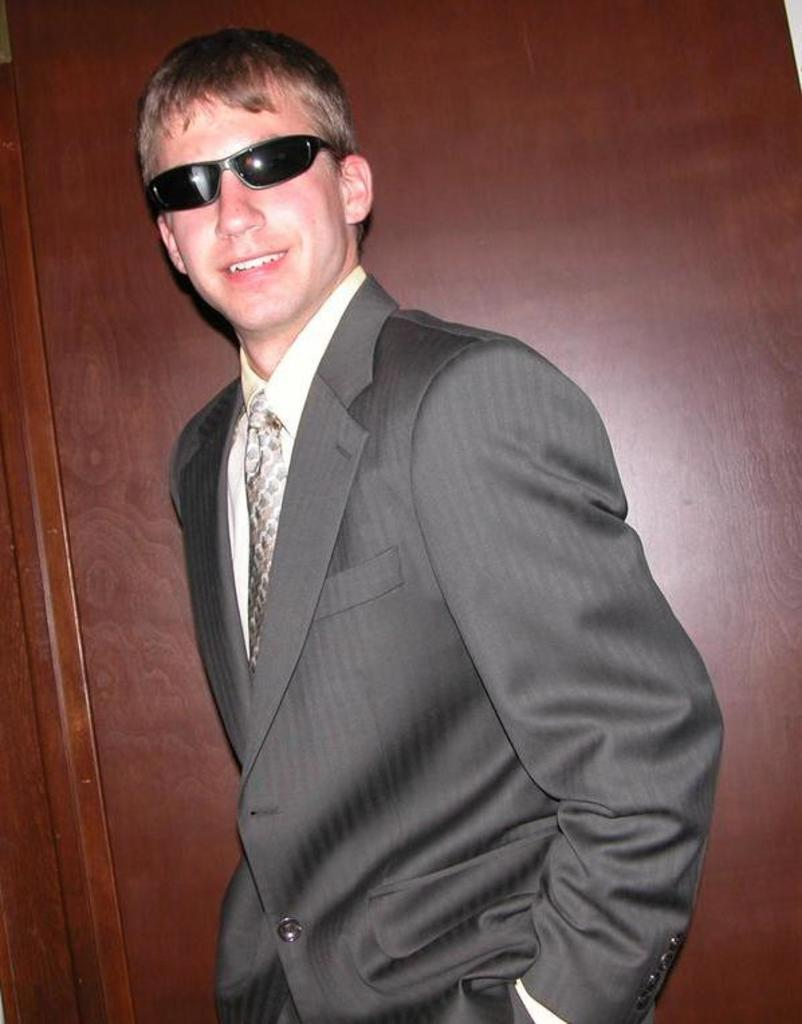What is the main subject of the image? There is a person standing in the image. What type of clothing is the person wearing? The person is wearing a blazer. What protective gear is the person wearing? The person is wearing goggles. Where is the person located in the image? The person is in the middle of the image. What can be seen in the background of the image? There is a wooden wall in the background of the image. What type of joke is the person telling in the image? There is no indication in the image that the person is telling a joke, so it cannot be determined from the picture. 